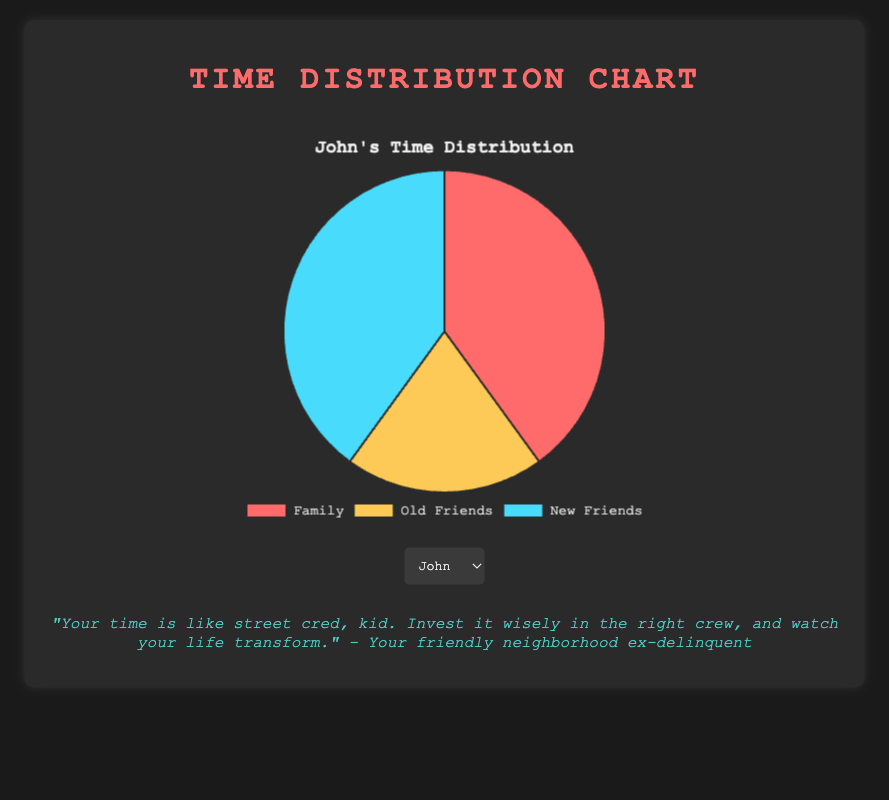How much more time does Maria spend with old friends compared to John? Maria spends 50% of her time with old friends while John spends 20%. The difference is 50% - 20% = 30%.
Answer: 30% What is the combined percentage of time Ella spends with her family and new friends? Ella spends 35% of her time with family and 40% with new friends. Combined, this is 35% + 40% = 75%.
Answer: 75% Which person's pie chart has the largest segment for new friends? By comparing the data, John, Alex, and Ella each spend 40% of their time with new friends, which is the largest segment among all participants.
Answer: John, Alex, and Ella Whose chart shows the smallest proportion of time spent with old friends? Alex spends the smallest proportion of time with old friends, which is 10%.
Answer: Alex How does Mike's time distribution compare to Maria's in terms of family time? Mike spends 25% of his time with family, whereas Maria spends 30%. Thus, Mike spends 5% less time with family compared to Maria.
Answer: Mike spends 5% less Which categories do Alex and John spend equal time on? Both Alex and John spend 40% of their time with new friends.
Answer: New friends Calculate the average percentage of time Ella spends with family, old friends, and new friends. Ella spends 35% of her time with family, 25% with old friends, and 40% with new friends. The average percentage is (35% + 25% + 40%) / 3 = 33.33%.
Answer: 33.33% Identify the person who spends equal time with their family and new friends. John spends 40% of his time with both his family and new friends.
Answer: John Who spends the most and the least amount of time with their family? Alex spends the most time with family at 50%, while Mike spends the least at 25%.
Answer: Alex (most), Mike (least) What percentage more time does John spend with new friends than old friends? John spends 40% of his time with new friends and 20% with old friends. The percentage more is (40% - 20%) = 20%.
Answer: 20% 